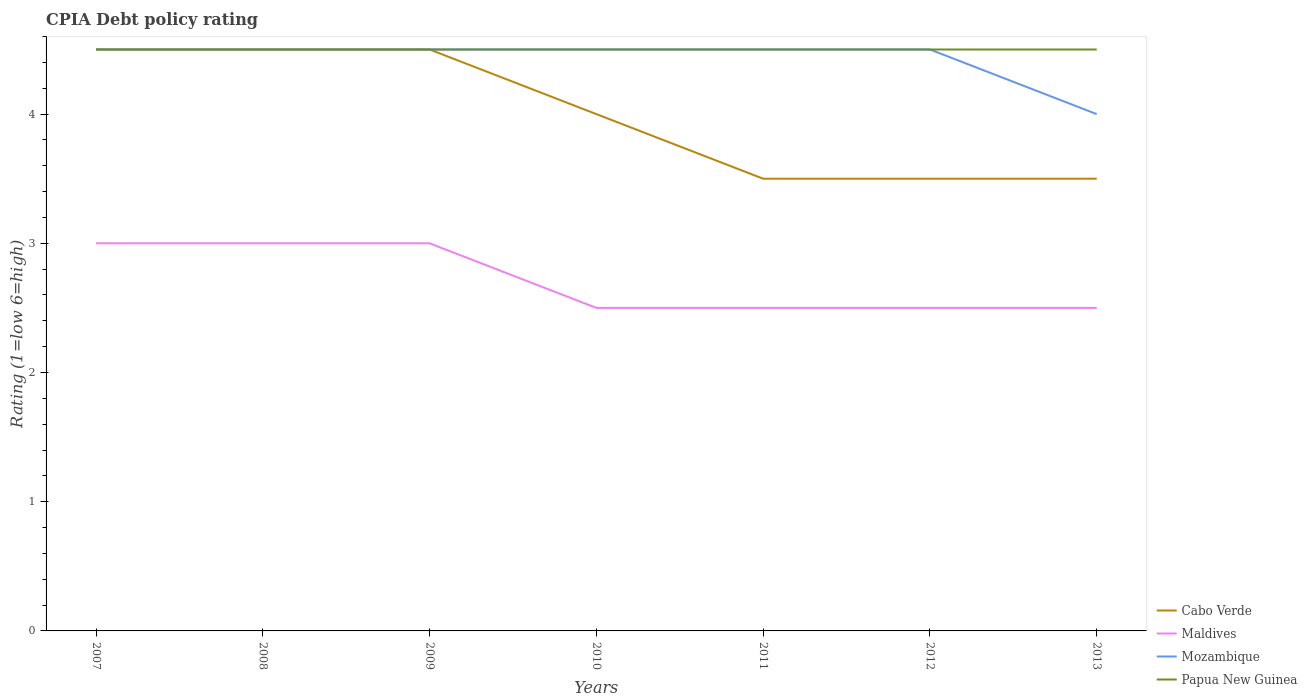How many different coloured lines are there?
Ensure brevity in your answer.  4. Is the number of lines equal to the number of legend labels?
Offer a terse response. Yes. Across all years, what is the maximum CPIA rating in Cabo Verde?
Keep it short and to the point. 3.5. In which year was the CPIA rating in Maldives maximum?
Provide a short and direct response. 2010. What is the difference between the highest and the second highest CPIA rating in Maldives?
Keep it short and to the point. 0.5. Is the CPIA rating in Cabo Verde strictly greater than the CPIA rating in Mozambique over the years?
Ensure brevity in your answer.  No. How many lines are there?
Provide a short and direct response. 4. What is the difference between two consecutive major ticks on the Y-axis?
Ensure brevity in your answer.  1. How many legend labels are there?
Give a very brief answer. 4. How are the legend labels stacked?
Make the answer very short. Vertical. What is the title of the graph?
Provide a short and direct response. CPIA Debt policy rating. What is the label or title of the Y-axis?
Give a very brief answer. Rating (1=low 6=high). What is the Rating (1=low 6=high) in Mozambique in 2008?
Provide a short and direct response. 4.5. What is the Rating (1=low 6=high) in Papua New Guinea in 2008?
Your answer should be compact. 4.5. What is the Rating (1=low 6=high) in Maldives in 2009?
Your answer should be compact. 3. What is the Rating (1=low 6=high) in Papua New Guinea in 2009?
Provide a short and direct response. 4.5. What is the Rating (1=low 6=high) in Cabo Verde in 2010?
Your answer should be very brief. 4. What is the Rating (1=low 6=high) in Maldives in 2010?
Keep it short and to the point. 2.5. What is the Rating (1=low 6=high) of Papua New Guinea in 2010?
Your response must be concise. 4.5. What is the Rating (1=low 6=high) in Mozambique in 2011?
Offer a very short reply. 4.5. What is the Rating (1=low 6=high) of Papua New Guinea in 2011?
Keep it short and to the point. 4.5. What is the Rating (1=low 6=high) in Cabo Verde in 2012?
Ensure brevity in your answer.  3.5. What is the Rating (1=low 6=high) of Maldives in 2013?
Provide a succinct answer. 2.5. What is the Rating (1=low 6=high) in Mozambique in 2013?
Your answer should be compact. 4. Across all years, what is the maximum Rating (1=low 6=high) in Maldives?
Offer a terse response. 3. Across all years, what is the minimum Rating (1=low 6=high) of Maldives?
Ensure brevity in your answer.  2.5. Across all years, what is the minimum Rating (1=low 6=high) of Mozambique?
Offer a terse response. 4. Across all years, what is the minimum Rating (1=low 6=high) of Papua New Guinea?
Keep it short and to the point. 4.5. What is the total Rating (1=low 6=high) in Cabo Verde in the graph?
Your answer should be compact. 28. What is the total Rating (1=low 6=high) of Maldives in the graph?
Provide a short and direct response. 19. What is the total Rating (1=low 6=high) of Mozambique in the graph?
Ensure brevity in your answer.  31. What is the total Rating (1=low 6=high) in Papua New Guinea in the graph?
Ensure brevity in your answer.  31.5. What is the difference between the Rating (1=low 6=high) in Cabo Verde in 2007 and that in 2008?
Provide a short and direct response. 0. What is the difference between the Rating (1=low 6=high) in Mozambique in 2007 and that in 2008?
Offer a very short reply. 0. What is the difference between the Rating (1=low 6=high) in Papua New Guinea in 2007 and that in 2008?
Offer a very short reply. 0. What is the difference between the Rating (1=low 6=high) in Maldives in 2007 and that in 2009?
Make the answer very short. 0. What is the difference between the Rating (1=low 6=high) of Mozambique in 2007 and that in 2009?
Offer a very short reply. 0. What is the difference between the Rating (1=low 6=high) in Maldives in 2007 and that in 2010?
Your answer should be compact. 0.5. What is the difference between the Rating (1=low 6=high) in Mozambique in 2007 and that in 2010?
Your answer should be compact. 0. What is the difference between the Rating (1=low 6=high) in Cabo Verde in 2007 and that in 2011?
Provide a succinct answer. 1. What is the difference between the Rating (1=low 6=high) in Maldives in 2007 and that in 2011?
Give a very brief answer. 0.5. What is the difference between the Rating (1=low 6=high) of Cabo Verde in 2007 and that in 2012?
Your answer should be very brief. 1. What is the difference between the Rating (1=low 6=high) in Maldives in 2007 and that in 2012?
Your answer should be very brief. 0.5. What is the difference between the Rating (1=low 6=high) of Mozambique in 2007 and that in 2012?
Ensure brevity in your answer.  0. What is the difference between the Rating (1=low 6=high) of Cabo Verde in 2007 and that in 2013?
Your answer should be compact. 1. What is the difference between the Rating (1=low 6=high) of Maldives in 2007 and that in 2013?
Ensure brevity in your answer.  0.5. What is the difference between the Rating (1=low 6=high) of Mozambique in 2007 and that in 2013?
Make the answer very short. 0.5. What is the difference between the Rating (1=low 6=high) of Cabo Verde in 2008 and that in 2010?
Ensure brevity in your answer.  0.5. What is the difference between the Rating (1=low 6=high) in Maldives in 2008 and that in 2010?
Offer a terse response. 0.5. What is the difference between the Rating (1=low 6=high) in Mozambique in 2008 and that in 2010?
Offer a very short reply. 0. What is the difference between the Rating (1=low 6=high) in Cabo Verde in 2008 and that in 2011?
Provide a succinct answer. 1. What is the difference between the Rating (1=low 6=high) in Mozambique in 2008 and that in 2011?
Your answer should be compact. 0. What is the difference between the Rating (1=low 6=high) of Maldives in 2008 and that in 2012?
Ensure brevity in your answer.  0.5. What is the difference between the Rating (1=low 6=high) of Cabo Verde in 2008 and that in 2013?
Provide a short and direct response. 1. What is the difference between the Rating (1=low 6=high) of Mozambique in 2008 and that in 2013?
Offer a very short reply. 0.5. What is the difference between the Rating (1=low 6=high) of Papua New Guinea in 2008 and that in 2013?
Your answer should be very brief. 0. What is the difference between the Rating (1=low 6=high) in Cabo Verde in 2009 and that in 2010?
Give a very brief answer. 0.5. What is the difference between the Rating (1=low 6=high) in Papua New Guinea in 2009 and that in 2010?
Your answer should be compact. 0. What is the difference between the Rating (1=low 6=high) of Maldives in 2009 and that in 2011?
Make the answer very short. 0.5. What is the difference between the Rating (1=low 6=high) in Mozambique in 2009 and that in 2011?
Give a very brief answer. 0. What is the difference between the Rating (1=low 6=high) of Mozambique in 2009 and that in 2012?
Your answer should be compact. 0. What is the difference between the Rating (1=low 6=high) of Papua New Guinea in 2009 and that in 2012?
Keep it short and to the point. 0. What is the difference between the Rating (1=low 6=high) in Cabo Verde in 2009 and that in 2013?
Provide a short and direct response. 1. What is the difference between the Rating (1=low 6=high) in Maldives in 2009 and that in 2013?
Your answer should be very brief. 0.5. What is the difference between the Rating (1=low 6=high) in Papua New Guinea in 2009 and that in 2013?
Your answer should be compact. 0. What is the difference between the Rating (1=low 6=high) in Maldives in 2010 and that in 2011?
Offer a very short reply. 0. What is the difference between the Rating (1=low 6=high) of Mozambique in 2010 and that in 2011?
Provide a short and direct response. 0. What is the difference between the Rating (1=low 6=high) of Cabo Verde in 2010 and that in 2012?
Provide a succinct answer. 0.5. What is the difference between the Rating (1=low 6=high) in Cabo Verde in 2010 and that in 2013?
Offer a terse response. 0.5. What is the difference between the Rating (1=low 6=high) in Maldives in 2010 and that in 2013?
Give a very brief answer. 0. What is the difference between the Rating (1=low 6=high) of Papua New Guinea in 2010 and that in 2013?
Your answer should be compact. 0. What is the difference between the Rating (1=low 6=high) in Maldives in 2011 and that in 2012?
Provide a succinct answer. 0. What is the difference between the Rating (1=low 6=high) of Mozambique in 2011 and that in 2012?
Your answer should be very brief. 0. What is the difference between the Rating (1=low 6=high) of Maldives in 2011 and that in 2013?
Your answer should be very brief. 0. What is the difference between the Rating (1=low 6=high) in Mozambique in 2011 and that in 2013?
Provide a succinct answer. 0.5. What is the difference between the Rating (1=low 6=high) in Papua New Guinea in 2011 and that in 2013?
Ensure brevity in your answer.  0. What is the difference between the Rating (1=low 6=high) in Maldives in 2012 and that in 2013?
Your answer should be compact. 0. What is the difference between the Rating (1=low 6=high) in Papua New Guinea in 2012 and that in 2013?
Your answer should be very brief. 0. What is the difference between the Rating (1=low 6=high) of Cabo Verde in 2007 and the Rating (1=low 6=high) of Maldives in 2009?
Offer a terse response. 1.5. What is the difference between the Rating (1=low 6=high) of Cabo Verde in 2007 and the Rating (1=low 6=high) of Mozambique in 2009?
Your response must be concise. 0. What is the difference between the Rating (1=low 6=high) in Cabo Verde in 2007 and the Rating (1=low 6=high) in Papua New Guinea in 2009?
Your answer should be very brief. 0. What is the difference between the Rating (1=low 6=high) of Maldives in 2007 and the Rating (1=low 6=high) of Mozambique in 2009?
Your response must be concise. -1.5. What is the difference between the Rating (1=low 6=high) in Maldives in 2007 and the Rating (1=low 6=high) in Papua New Guinea in 2009?
Your answer should be compact. -1.5. What is the difference between the Rating (1=low 6=high) in Mozambique in 2007 and the Rating (1=low 6=high) in Papua New Guinea in 2009?
Your answer should be very brief. 0. What is the difference between the Rating (1=low 6=high) in Cabo Verde in 2007 and the Rating (1=low 6=high) in Maldives in 2010?
Your response must be concise. 2. What is the difference between the Rating (1=low 6=high) in Cabo Verde in 2007 and the Rating (1=low 6=high) in Papua New Guinea in 2010?
Keep it short and to the point. 0. What is the difference between the Rating (1=low 6=high) in Mozambique in 2007 and the Rating (1=low 6=high) in Papua New Guinea in 2010?
Offer a terse response. 0. What is the difference between the Rating (1=low 6=high) in Cabo Verde in 2007 and the Rating (1=low 6=high) in Maldives in 2011?
Provide a short and direct response. 2. What is the difference between the Rating (1=low 6=high) of Maldives in 2007 and the Rating (1=low 6=high) of Mozambique in 2011?
Ensure brevity in your answer.  -1.5. What is the difference between the Rating (1=low 6=high) in Maldives in 2007 and the Rating (1=low 6=high) in Papua New Guinea in 2011?
Offer a terse response. -1.5. What is the difference between the Rating (1=low 6=high) in Mozambique in 2007 and the Rating (1=low 6=high) in Papua New Guinea in 2011?
Give a very brief answer. 0. What is the difference between the Rating (1=low 6=high) in Cabo Verde in 2007 and the Rating (1=low 6=high) in Maldives in 2012?
Keep it short and to the point. 2. What is the difference between the Rating (1=low 6=high) in Cabo Verde in 2007 and the Rating (1=low 6=high) in Mozambique in 2013?
Provide a short and direct response. 0.5. What is the difference between the Rating (1=low 6=high) in Maldives in 2007 and the Rating (1=low 6=high) in Papua New Guinea in 2013?
Offer a terse response. -1.5. What is the difference between the Rating (1=low 6=high) in Mozambique in 2007 and the Rating (1=low 6=high) in Papua New Guinea in 2013?
Keep it short and to the point. 0. What is the difference between the Rating (1=low 6=high) in Cabo Verde in 2008 and the Rating (1=low 6=high) in Maldives in 2009?
Your answer should be compact. 1.5. What is the difference between the Rating (1=low 6=high) of Cabo Verde in 2008 and the Rating (1=low 6=high) of Mozambique in 2009?
Provide a succinct answer. 0. What is the difference between the Rating (1=low 6=high) in Maldives in 2008 and the Rating (1=low 6=high) in Mozambique in 2009?
Offer a terse response. -1.5. What is the difference between the Rating (1=low 6=high) of Maldives in 2008 and the Rating (1=low 6=high) of Papua New Guinea in 2009?
Your answer should be compact. -1.5. What is the difference between the Rating (1=low 6=high) in Cabo Verde in 2008 and the Rating (1=low 6=high) in Maldives in 2010?
Offer a very short reply. 2. What is the difference between the Rating (1=low 6=high) of Maldives in 2008 and the Rating (1=low 6=high) of Mozambique in 2010?
Ensure brevity in your answer.  -1.5. What is the difference between the Rating (1=low 6=high) in Maldives in 2008 and the Rating (1=low 6=high) in Papua New Guinea in 2010?
Your answer should be very brief. -1.5. What is the difference between the Rating (1=low 6=high) of Cabo Verde in 2008 and the Rating (1=low 6=high) of Maldives in 2011?
Your response must be concise. 2. What is the difference between the Rating (1=low 6=high) of Cabo Verde in 2008 and the Rating (1=low 6=high) of Mozambique in 2011?
Provide a succinct answer. 0. What is the difference between the Rating (1=low 6=high) in Cabo Verde in 2008 and the Rating (1=low 6=high) in Papua New Guinea in 2011?
Ensure brevity in your answer.  0. What is the difference between the Rating (1=low 6=high) in Maldives in 2008 and the Rating (1=low 6=high) in Papua New Guinea in 2011?
Ensure brevity in your answer.  -1.5. What is the difference between the Rating (1=low 6=high) in Cabo Verde in 2008 and the Rating (1=low 6=high) in Maldives in 2012?
Give a very brief answer. 2. What is the difference between the Rating (1=low 6=high) of Cabo Verde in 2008 and the Rating (1=low 6=high) of Mozambique in 2012?
Make the answer very short. 0. What is the difference between the Rating (1=low 6=high) in Maldives in 2008 and the Rating (1=low 6=high) in Papua New Guinea in 2012?
Make the answer very short. -1.5. What is the difference between the Rating (1=low 6=high) in Mozambique in 2008 and the Rating (1=low 6=high) in Papua New Guinea in 2012?
Provide a succinct answer. 0. What is the difference between the Rating (1=low 6=high) in Cabo Verde in 2008 and the Rating (1=low 6=high) in Maldives in 2013?
Provide a short and direct response. 2. What is the difference between the Rating (1=low 6=high) in Cabo Verde in 2008 and the Rating (1=low 6=high) in Mozambique in 2013?
Give a very brief answer. 0.5. What is the difference between the Rating (1=low 6=high) of Cabo Verde in 2008 and the Rating (1=low 6=high) of Papua New Guinea in 2013?
Keep it short and to the point. 0. What is the difference between the Rating (1=low 6=high) of Maldives in 2008 and the Rating (1=low 6=high) of Mozambique in 2013?
Ensure brevity in your answer.  -1. What is the difference between the Rating (1=low 6=high) in Cabo Verde in 2009 and the Rating (1=low 6=high) in Papua New Guinea in 2010?
Offer a very short reply. 0. What is the difference between the Rating (1=low 6=high) of Mozambique in 2009 and the Rating (1=low 6=high) of Papua New Guinea in 2010?
Keep it short and to the point. 0. What is the difference between the Rating (1=low 6=high) of Cabo Verde in 2009 and the Rating (1=low 6=high) of Maldives in 2011?
Make the answer very short. 2. What is the difference between the Rating (1=low 6=high) of Cabo Verde in 2009 and the Rating (1=low 6=high) of Mozambique in 2011?
Provide a succinct answer. 0. What is the difference between the Rating (1=low 6=high) in Cabo Verde in 2009 and the Rating (1=low 6=high) in Papua New Guinea in 2011?
Ensure brevity in your answer.  0. What is the difference between the Rating (1=low 6=high) in Maldives in 2009 and the Rating (1=low 6=high) in Mozambique in 2011?
Make the answer very short. -1.5. What is the difference between the Rating (1=low 6=high) in Mozambique in 2009 and the Rating (1=low 6=high) in Papua New Guinea in 2011?
Ensure brevity in your answer.  0. What is the difference between the Rating (1=low 6=high) in Cabo Verde in 2009 and the Rating (1=low 6=high) in Papua New Guinea in 2012?
Offer a terse response. 0. What is the difference between the Rating (1=low 6=high) in Maldives in 2009 and the Rating (1=low 6=high) in Mozambique in 2012?
Provide a short and direct response. -1.5. What is the difference between the Rating (1=low 6=high) of Mozambique in 2009 and the Rating (1=low 6=high) of Papua New Guinea in 2012?
Your answer should be compact. 0. What is the difference between the Rating (1=low 6=high) of Cabo Verde in 2009 and the Rating (1=low 6=high) of Mozambique in 2013?
Offer a very short reply. 0.5. What is the difference between the Rating (1=low 6=high) in Mozambique in 2009 and the Rating (1=low 6=high) in Papua New Guinea in 2013?
Ensure brevity in your answer.  0. What is the difference between the Rating (1=low 6=high) of Cabo Verde in 2010 and the Rating (1=low 6=high) of Maldives in 2011?
Your answer should be very brief. 1.5. What is the difference between the Rating (1=low 6=high) of Maldives in 2010 and the Rating (1=low 6=high) of Mozambique in 2011?
Your response must be concise. -2. What is the difference between the Rating (1=low 6=high) of Maldives in 2010 and the Rating (1=low 6=high) of Papua New Guinea in 2011?
Offer a terse response. -2. What is the difference between the Rating (1=low 6=high) of Mozambique in 2010 and the Rating (1=low 6=high) of Papua New Guinea in 2011?
Your answer should be compact. 0. What is the difference between the Rating (1=low 6=high) in Cabo Verde in 2010 and the Rating (1=low 6=high) in Mozambique in 2012?
Keep it short and to the point. -0.5. What is the difference between the Rating (1=low 6=high) in Cabo Verde in 2010 and the Rating (1=low 6=high) in Papua New Guinea in 2012?
Offer a very short reply. -0.5. What is the difference between the Rating (1=low 6=high) of Cabo Verde in 2010 and the Rating (1=low 6=high) of Maldives in 2013?
Make the answer very short. 1.5. What is the difference between the Rating (1=low 6=high) in Cabo Verde in 2010 and the Rating (1=low 6=high) in Mozambique in 2013?
Keep it short and to the point. 0. What is the difference between the Rating (1=low 6=high) of Cabo Verde in 2010 and the Rating (1=low 6=high) of Papua New Guinea in 2013?
Give a very brief answer. -0.5. What is the difference between the Rating (1=low 6=high) in Maldives in 2010 and the Rating (1=low 6=high) in Mozambique in 2013?
Keep it short and to the point. -1.5. What is the difference between the Rating (1=low 6=high) in Cabo Verde in 2011 and the Rating (1=low 6=high) in Maldives in 2012?
Provide a short and direct response. 1. What is the difference between the Rating (1=low 6=high) in Cabo Verde in 2011 and the Rating (1=low 6=high) in Mozambique in 2012?
Your response must be concise. -1. What is the difference between the Rating (1=low 6=high) in Maldives in 2011 and the Rating (1=low 6=high) in Papua New Guinea in 2012?
Provide a succinct answer. -2. What is the difference between the Rating (1=low 6=high) in Mozambique in 2011 and the Rating (1=low 6=high) in Papua New Guinea in 2012?
Offer a terse response. 0. What is the difference between the Rating (1=low 6=high) in Cabo Verde in 2011 and the Rating (1=low 6=high) in Maldives in 2013?
Provide a succinct answer. 1. What is the difference between the Rating (1=low 6=high) of Cabo Verde in 2011 and the Rating (1=low 6=high) of Mozambique in 2013?
Make the answer very short. -0.5. What is the difference between the Rating (1=low 6=high) in Maldives in 2011 and the Rating (1=low 6=high) in Papua New Guinea in 2013?
Offer a terse response. -2. What is the difference between the Rating (1=low 6=high) of Mozambique in 2011 and the Rating (1=low 6=high) of Papua New Guinea in 2013?
Offer a terse response. 0. What is the difference between the Rating (1=low 6=high) of Cabo Verde in 2012 and the Rating (1=low 6=high) of Maldives in 2013?
Your answer should be very brief. 1. What is the difference between the Rating (1=low 6=high) of Cabo Verde in 2012 and the Rating (1=low 6=high) of Papua New Guinea in 2013?
Give a very brief answer. -1. What is the difference between the Rating (1=low 6=high) in Maldives in 2012 and the Rating (1=low 6=high) in Mozambique in 2013?
Your answer should be very brief. -1.5. What is the difference between the Rating (1=low 6=high) in Mozambique in 2012 and the Rating (1=low 6=high) in Papua New Guinea in 2013?
Your response must be concise. 0. What is the average Rating (1=low 6=high) of Maldives per year?
Keep it short and to the point. 2.71. What is the average Rating (1=low 6=high) of Mozambique per year?
Your answer should be compact. 4.43. In the year 2007, what is the difference between the Rating (1=low 6=high) of Cabo Verde and Rating (1=low 6=high) of Maldives?
Keep it short and to the point. 1.5. In the year 2007, what is the difference between the Rating (1=low 6=high) of Cabo Verde and Rating (1=low 6=high) of Papua New Guinea?
Provide a short and direct response. 0. In the year 2007, what is the difference between the Rating (1=low 6=high) of Maldives and Rating (1=low 6=high) of Papua New Guinea?
Ensure brevity in your answer.  -1.5. In the year 2008, what is the difference between the Rating (1=low 6=high) of Mozambique and Rating (1=low 6=high) of Papua New Guinea?
Make the answer very short. 0. In the year 2009, what is the difference between the Rating (1=low 6=high) in Cabo Verde and Rating (1=low 6=high) in Maldives?
Provide a succinct answer. 1.5. In the year 2009, what is the difference between the Rating (1=low 6=high) in Cabo Verde and Rating (1=low 6=high) in Mozambique?
Your response must be concise. 0. In the year 2009, what is the difference between the Rating (1=low 6=high) of Maldives and Rating (1=low 6=high) of Mozambique?
Keep it short and to the point. -1.5. In the year 2009, what is the difference between the Rating (1=low 6=high) of Maldives and Rating (1=low 6=high) of Papua New Guinea?
Keep it short and to the point. -1.5. In the year 2010, what is the difference between the Rating (1=low 6=high) in Cabo Verde and Rating (1=low 6=high) in Mozambique?
Ensure brevity in your answer.  -0.5. In the year 2010, what is the difference between the Rating (1=low 6=high) in Cabo Verde and Rating (1=low 6=high) in Papua New Guinea?
Offer a terse response. -0.5. In the year 2010, what is the difference between the Rating (1=low 6=high) in Maldives and Rating (1=low 6=high) in Mozambique?
Offer a terse response. -2. In the year 2010, what is the difference between the Rating (1=low 6=high) in Maldives and Rating (1=low 6=high) in Papua New Guinea?
Keep it short and to the point. -2. In the year 2010, what is the difference between the Rating (1=low 6=high) in Mozambique and Rating (1=low 6=high) in Papua New Guinea?
Offer a terse response. 0. In the year 2011, what is the difference between the Rating (1=low 6=high) in Cabo Verde and Rating (1=low 6=high) in Mozambique?
Your answer should be very brief. -1. In the year 2011, what is the difference between the Rating (1=low 6=high) of Cabo Verde and Rating (1=low 6=high) of Papua New Guinea?
Your response must be concise. -1. In the year 2011, what is the difference between the Rating (1=low 6=high) in Maldives and Rating (1=low 6=high) in Mozambique?
Offer a very short reply. -2. In the year 2011, what is the difference between the Rating (1=low 6=high) in Maldives and Rating (1=low 6=high) in Papua New Guinea?
Offer a very short reply. -2. In the year 2011, what is the difference between the Rating (1=low 6=high) in Mozambique and Rating (1=low 6=high) in Papua New Guinea?
Give a very brief answer. 0. In the year 2012, what is the difference between the Rating (1=low 6=high) of Maldives and Rating (1=low 6=high) of Papua New Guinea?
Your answer should be compact. -2. In the year 2013, what is the difference between the Rating (1=low 6=high) of Cabo Verde and Rating (1=low 6=high) of Maldives?
Your response must be concise. 1. In the year 2013, what is the difference between the Rating (1=low 6=high) of Cabo Verde and Rating (1=low 6=high) of Mozambique?
Your response must be concise. -0.5. In the year 2013, what is the difference between the Rating (1=low 6=high) of Cabo Verde and Rating (1=low 6=high) of Papua New Guinea?
Your response must be concise. -1. In the year 2013, what is the difference between the Rating (1=low 6=high) in Maldives and Rating (1=low 6=high) in Mozambique?
Provide a short and direct response. -1.5. In the year 2013, what is the difference between the Rating (1=low 6=high) in Maldives and Rating (1=low 6=high) in Papua New Guinea?
Your answer should be very brief. -2. In the year 2013, what is the difference between the Rating (1=low 6=high) in Mozambique and Rating (1=low 6=high) in Papua New Guinea?
Make the answer very short. -0.5. What is the ratio of the Rating (1=low 6=high) in Cabo Verde in 2007 to that in 2008?
Offer a very short reply. 1. What is the ratio of the Rating (1=low 6=high) in Papua New Guinea in 2007 to that in 2008?
Your answer should be very brief. 1. What is the ratio of the Rating (1=low 6=high) of Cabo Verde in 2007 to that in 2009?
Make the answer very short. 1. What is the ratio of the Rating (1=low 6=high) in Maldives in 2007 to that in 2009?
Provide a succinct answer. 1. What is the ratio of the Rating (1=low 6=high) in Cabo Verde in 2007 to that in 2010?
Keep it short and to the point. 1.12. What is the ratio of the Rating (1=low 6=high) of Maldives in 2007 to that in 2010?
Offer a very short reply. 1.2. What is the ratio of the Rating (1=low 6=high) in Papua New Guinea in 2007 to that in 2010?
Your answer should be compact. 1. What is the ratio of the Rating (1=low 6=high) in Papua New Guinea in 2007 to that in 2011?
Provide a short and direct response. 1. What is the ratio of the Rating (1=low 6=high) in Maldives in 2007 to that in 2012?
Your response must be concise. 1.2. What is the ratio of the Rating (1=low 6=high) of Papua New Guinea in 2007 to that in 2012?
Ensure brevity in your answer.  1. What is the ratio of the Rating (1=low 6=high) of Cabo Verde in 2007 to that in 2013?
Your response must be concise. 1.29. What is the ratio of the Rating (1=low 6=high) in Papua New Guinea in 2007 to that in 2013?
Offer a terse response. 1. What is the ratio of the Rating (1=low 6=high) in Maldives in 2008 to that in 2009?
Offer a terse response. 1. What is the ratio of the Rating (1=low 6=high) of Papua New Guinea in 2008 to that in 2009?
Your answer should be very brief. 1. What is the ratio of the Rating (1=low 6=high) of Cabo Verde in 2008 to that in 2010?
Your answer should be very brief. 1.12. What is the ratio of the Rating (1=low 6=high) in Mozambique in 2008 to that in 2010?
Provide a short and direct response. 1. What is the ratio of the Rating (1=low 6=high) in Papua New Guinea in 2008 to that in 2010?
Make the answer very short. 1. What is the ratio of the Rating (1=low 6=high) of Cabo Verde in 2008 to that in 2012?
Give a very brief answer. 1.29. What is the ratio of the Rating (1=low 6=high) in Mozambique in 2008 to that in 2012?
Your answer should be compact. 1. What is the ratio of the Rating (1=low 6=high) in Papua New Guinea in 2008 to that in 2012?
Provide a short and direct response. 1. What is the ratio of the Rating (1=low 6=high) in Cabo Verde in 2008 to that in 2013?
Make the answer very short. 1.29. What is the ratio of the Rating (1=low 6=high) of Maldives in 2009 to that in 2010?
Your response must be concise. 1.2. What is the ratio of the Rating (1=low 6=high) of Mozambique in 2009 to that in 2010?
Ensure brevity in your answer.  1. What is the ratio of the Rating (1=low 6=high) in Cabo Verde in 2009 to that in 2011?
Provide a succinct answer. 1.29. What is the ratio of the Rating (1=low 6=high) in Maldives in 2009 to that in 2011?
Provide a short and direct response. 1.2. What is the ratio of the Rating (1=low 6=high) in Papua New Guinea in 2009 to that in 2011?
Offer a terse response. 1. What is the ratio of the Rating (1=low 6=high) of Papua New Guinea in 2009 to that in 2012?
Your answer should be compact. 1. What is the ratio of the Rating (1=low 6=high) of Cabo Verde in 2009 to that in 2013?
Ensure brevity in your answer.  1.29. What is the ratio of the Rating (1=low 6=high) in Maldives in 2009 to that in 2013?
Your answer should be very brief. 1.2. What is the ratio of the Rating (1=low 6=high) of Mozambique in 2009 to that in 2013?
Offer a terse response. 1.12. What is the ratio of the Rating (1=low 6=high) in Papua New Guinea in 2009 to that in 2013?
Provide a succinct answer. 1. What is the ratio of the Rating (1=low 6=high) in Cabo Verde in 2010 to that in 2011?
Make the answer very short. 1.14. What is the ratio of the Rating (1=low 6=high) of Maldives in 2010 to that in 2011?
Your answer should be very brief. 1. What is the ratio of the Rating (1=low 6=high) of Cabo Verde in 2010 to that in 2012?
Give a very brief answer. 1.14. What is the ratio of the Rating (1=low 6=high) of Maldives in 2010 to that in 2012?
Offer a very short reply. 1. What is the ratio of the Rating (1=low 6=high) of Maldives in 2010 to that in 2013?
Give a very brief answer. 1. What is the ratio of the Rating (1=low 6=high) in Mozambique in 2010 to that in 2013?
Your answer should be very brief. 1.12. What is the ratio of the Rating (1=low 6=high) of Maldives in 2011 to that in 2012?
Offer a terse response. 1. What is the ratio of the Rating (1=low 6=high) in Mozambique in 2011 to that in 2012?
Provide a short and direct response. 1. What is the ratio of the Rating (1=low 6=high) in Cabo Verde in 2011 to that in 2013?
Offer a terse response. 1. What is the ratio of the Rating (1=low 6=high) of Maldives in 2011 to that in 2013?
Offer a very short reply. 1. What is the ratio of the Rating (1=low 6=high) of Mozambique in 2011 to that in 2013?
Keep it short and to the point. 1.12. What is the ratio of the Rating (1=low 6=high) in Papua New Guinea in 2011 to that in 2013?
Give a very brief answer. 1. What is the ratio of the Rating (1=low 6=high) in Maldives in 2012 to that in 2013?
Your answer should be very brief. 1. What is the ratio of the Rating (1=low 6=high) of Mozambique in 2012 to that in 2013?
Keep it short and to the point. 1.12. What is the difference between the highest and the second highest Rating (1=low 6=high) in Maldives?
Give a very brief answer. 0. What is the difference between the highest and the second highest Rating (1=low 6=high) of Mozambique?
Offer a very short reply. 0. What is the difference between the highest and the lowest Rating (1=low 6=high) of Papua New Guinea?
Your answer should be compact. 0. 